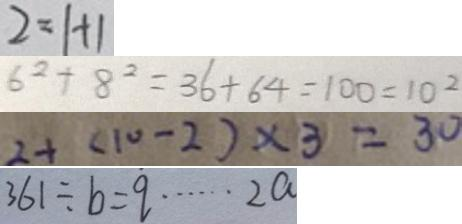<formula> <loc_0><loc_0><loc_500><loc_500>2 = 1 + 1 
 6 ^ { 2 } + 8 ^ { 2 } = 3 6 + 6 4 = 1 0 0 = 1 0 ^ { 2 } 
 2 + ( 1 0 - 2 ) \times 3 = 3 0 
 3 6 1 \div b = q \cdots 2 a</formula> 